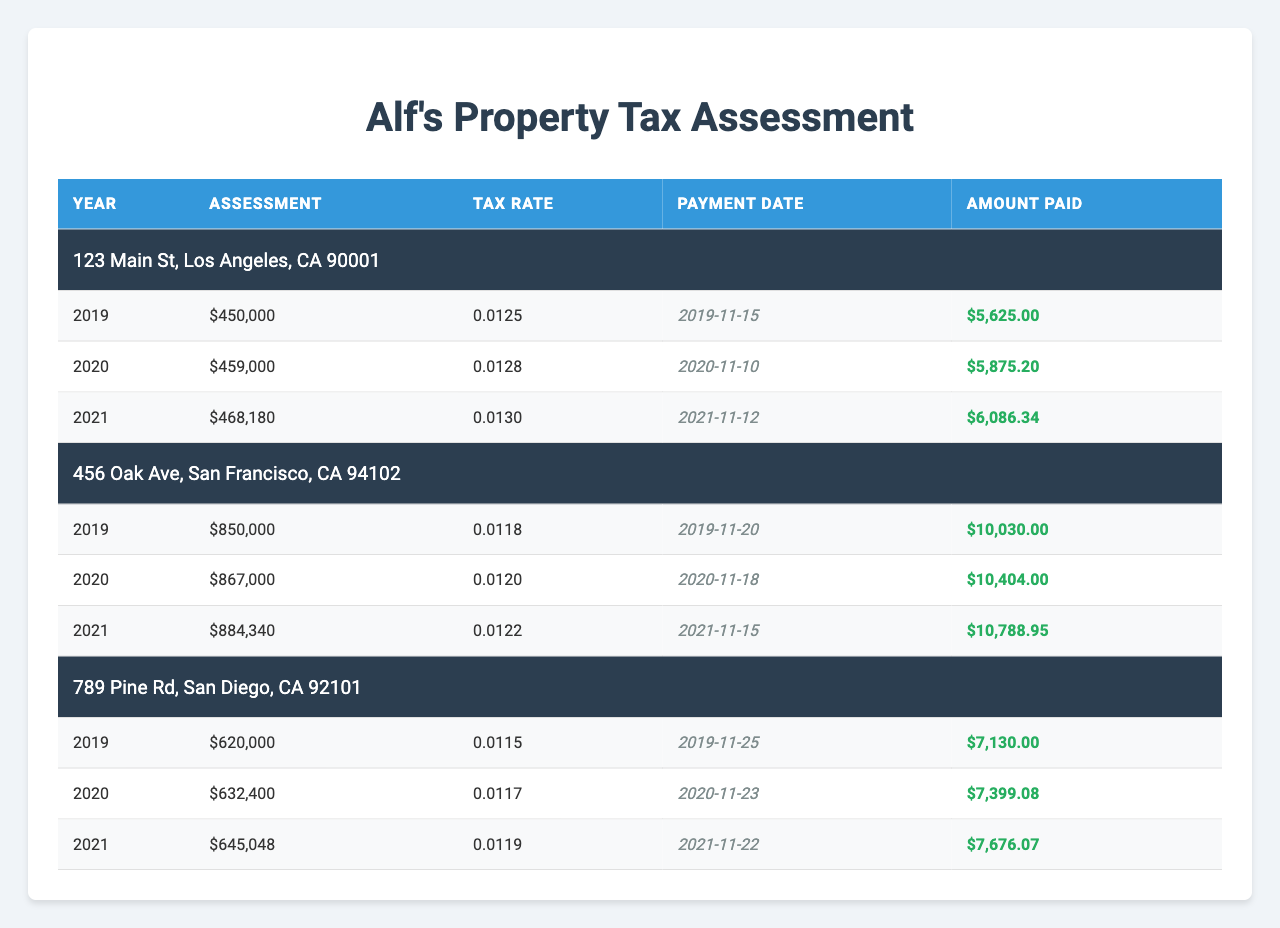What's the assessment amount for the property at 123 Main St in 2021? Looking at the table, under the property at 123 Main St, the assessment for the year 2021 is listed as $468,180.
Answer: $468,180 What tax rate was applied to the property at 456 Oak Ave in 2020? For the property at 456 Oak Ave, in the year 2020, the tax rate displayed is 0.0120.
Answer: 0.0120 Which property had the highest amount paid in property taxes in 2019? Reviewing the payments for 2019, the amounts paid were: $5,625 for 123 Main St, $10,030 for 456 Oak Ave, and $7,130 for 789 Pine Rd. The highest amount is $10,030 for 456 Oak Ave.
Answer: 456 Oak Ave What is the total amount paid for the property at 789 Pine Rd over the three years? The amounts paid for 789 Pine Rd are: $7,130 (2019) + $7,399.08 (2020) + $7,676.07 (2021) = $22,205.15 as the total.
Answer: $22,205.15 Did Alf pay more in total for the property at 456 Oak Ave compared to 123 Main St over the three years? The sums are $10,030 + $10,404 + $10,788.95 = $31,222.95 for 456 Oak Ave and $5,625 + $5,875.20 + $6,086.34 = $17,586.54 for 123 Main St. Since $31,222.95 > $17,586.54, the answer is yes.
Answer: Yes What is the average assessment value for the property at 123 Main St over the years? The assessments are $450,000 (2019), $459,000 (2020), and $468,180 (2021). The average is calculated as ($450,000 + $459,000 + $468,180) / 3 = $459,060.
Answer: $459,060 Which property had the lowest tax rate in 2019, and what was that rate? The tax rates for 2019 are: 0.0125 for 123 Main St, 0.0118 for 456 Oak Ave, and 0.0115 for 789 Pine Rd. The lowest rate is 0.0115 for 789 Pine Rd.
Answer: 789 Pine Rd, 0.0115 What is the difference in the assessment amount between the highest and lowest assessed properties in 2021? The highest assessment in 2021 is $884,340 for 456 Oak Ave, and the lowest is $645,048 for 789 Pine Rd. The difference is $884,340 - $645,048 = $239,292.
Answer: $239,292 Did Alf make his property tax payment for 2019 on time for all properties? The payment dates were: 123 Main St on 2019-11-15, 456 Oak Ave on 2019-11-20, and 789 Pine Rd on 2019-11-25. All are within the range for timely payment, so the answer is yes.
Answer: Yes Which year did Alf pay the highest tax rate across all properties? The tax rates for each year are as follows: 2019 is 0.0125, 0.0118, 0.0115; 2020 is 0.0128, 0.0120, 0.0117; 2021 is 0.0130, 0.0122, 0.0119. The highest rate is 0.0130 for the year 2021.
Answer: 2021 